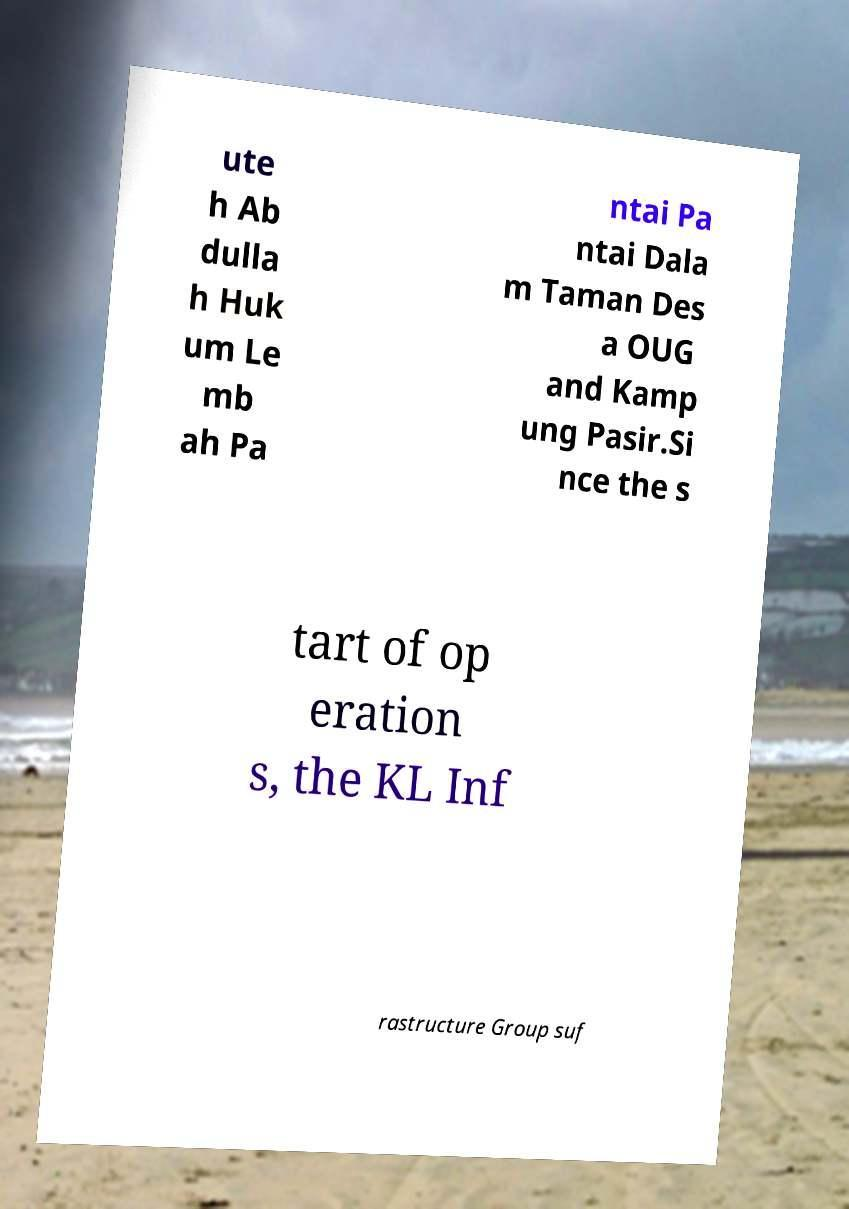For documentation purposes, I need the text within this image transcribed. Could you provide that? ute h Ab dulla h Huk um Le mb ah Pa ntai Pa ntai Dala m Taman Des a OUG and Kamp ung Pasir.Si nce the s tart of op eration s, the KL Inf rastructure Group suf 